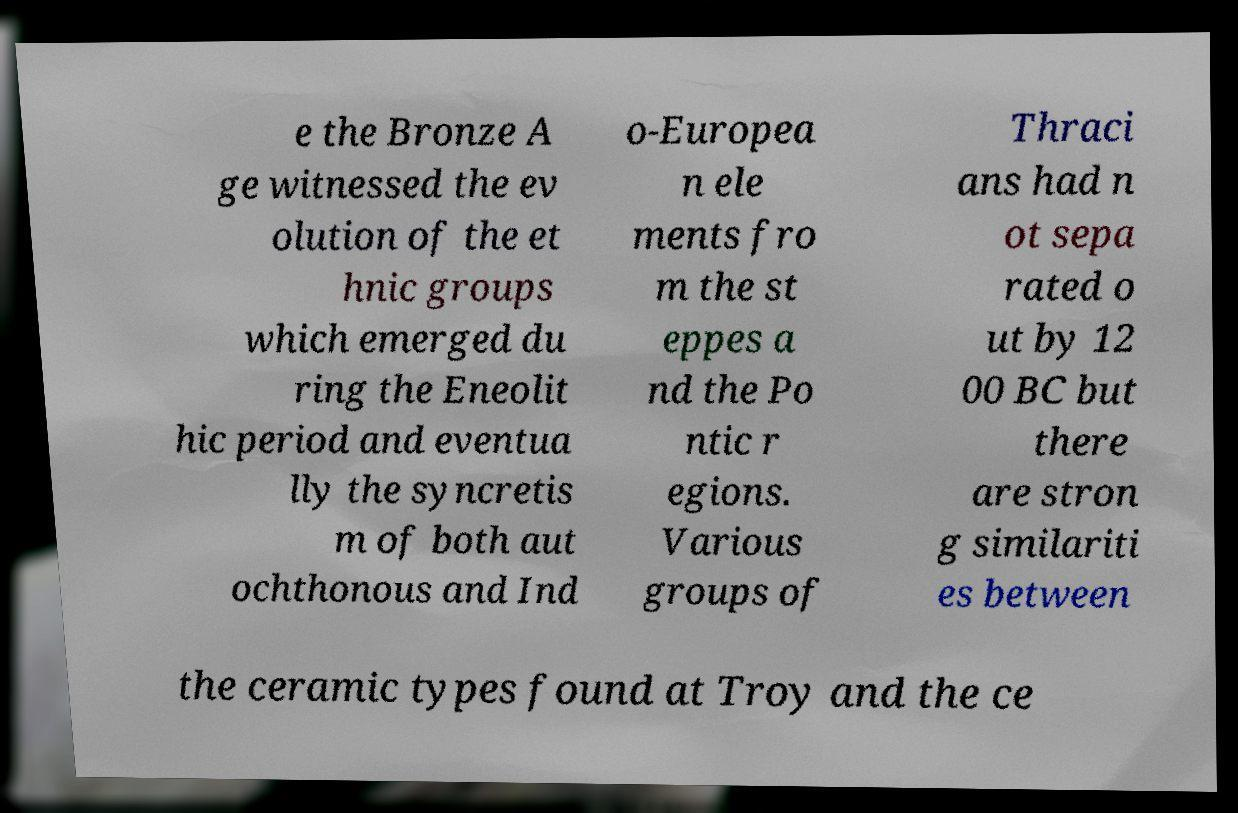Can you read and provide the text displayed in the image?This photo seems to have some interesting text. Can you extract and type it out for me? e the Bronze A ge witnessed the ev olution of the et hnic groups which emerged du ring the Eneolit hic period and eventua lly the syncretis m of both aut ochthonous and Ind o-Europea n ele ments fro m the st eppes a nd the Po ntic r egions. Various groups of Thraci ans had n ot sepa rated o ut by 12 00 BC but there are stron g similariti es between the ceramic types found at Troy and the ce 